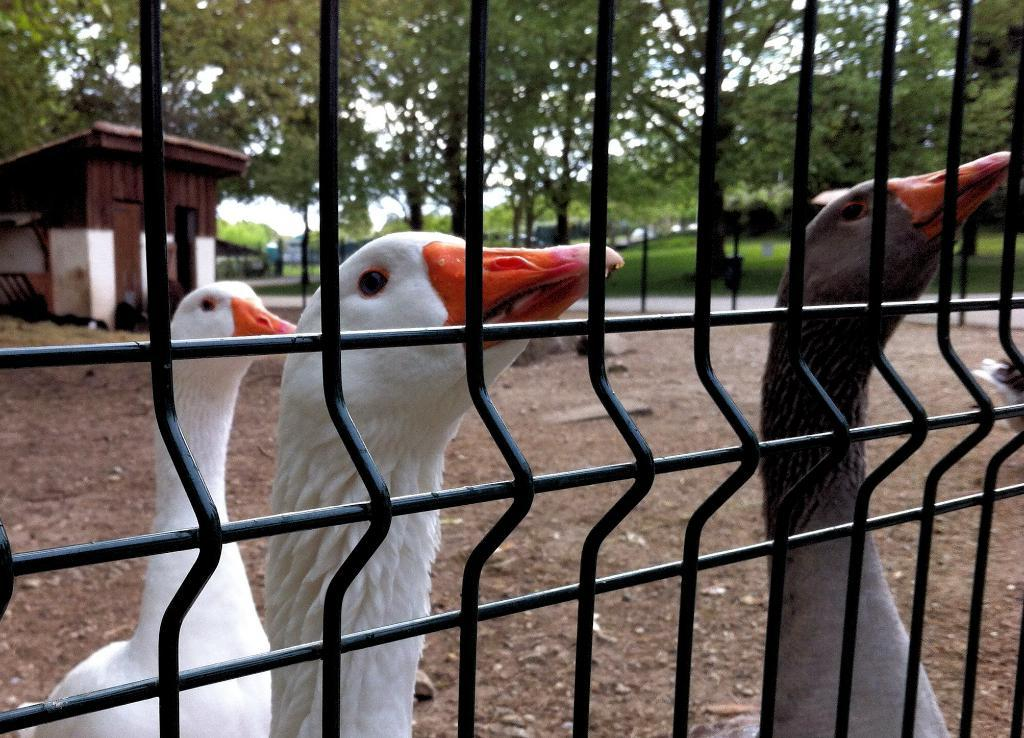What structure is present in the image? There is a cage in the image. What is located behind the cage? There are birds behind the cage. What type of vegetation can be seen in the image? There are trees in the image. What is the ground covered with in the image? There is grass on the ground. What type of building is visible in the image? There is a hut in the image. How long does it take for the train to pass by the hut in the image? There is no train present in the image, so it is not possible to determine how long it would take for a train to pass by the hut. 